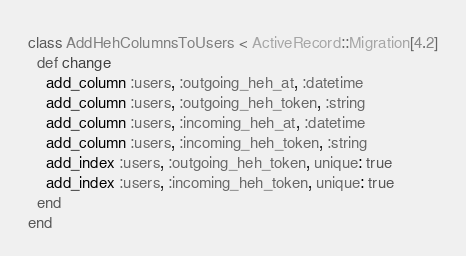<code> <loc_0><loc_0><loc_500><loc_500><_Ruby_>class AddHehColumnsToUsers < ActiveRecord::Migration[4.2]
  def change
    add_column :users, :outgoing_heh_at, :datetime
    add_column :users, :outgoing_heh_token, :string
    add_column :users, :incoming_heh_at, :datetime
    add_column :users, :incoming_heh_token, :string
    add_index :users, :outgoing_heh_token, unique: true
    add_index :users, :incoming_heh_token, unique: true
  end
end
</code> 